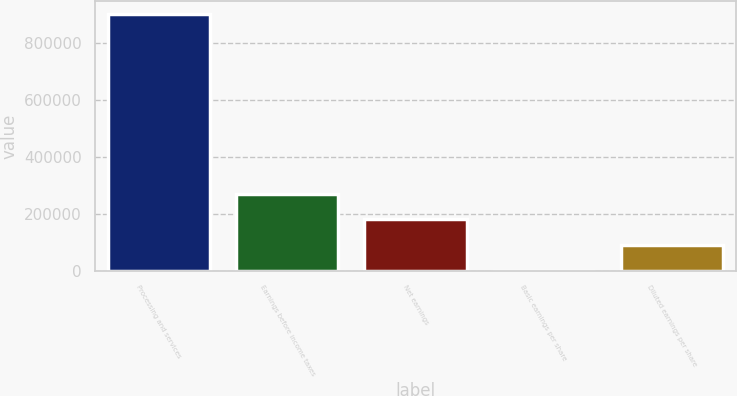Convert chart to OTSL. <chart><loc_0><loc_0><loc_500><loc_500><bar_chart><fcel>Processing and services<fcel>Earnings before income taxes<fcel>Net earnings<fcel>Basic earnings per share<fcel>Diluted earnings per share<nl><fcel>900936<fcel>270281<fcel>180187<fcel>0.23<fcel>90093.8<nl></chart> 